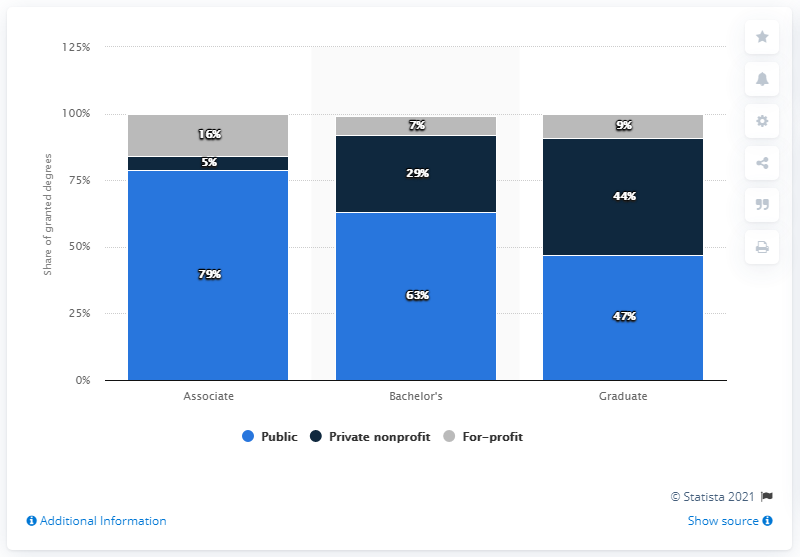Mention a couple of crucial points in this snapshot. The blue bar percentage value in Associate is 79%. The average of the blue bar is 63. 